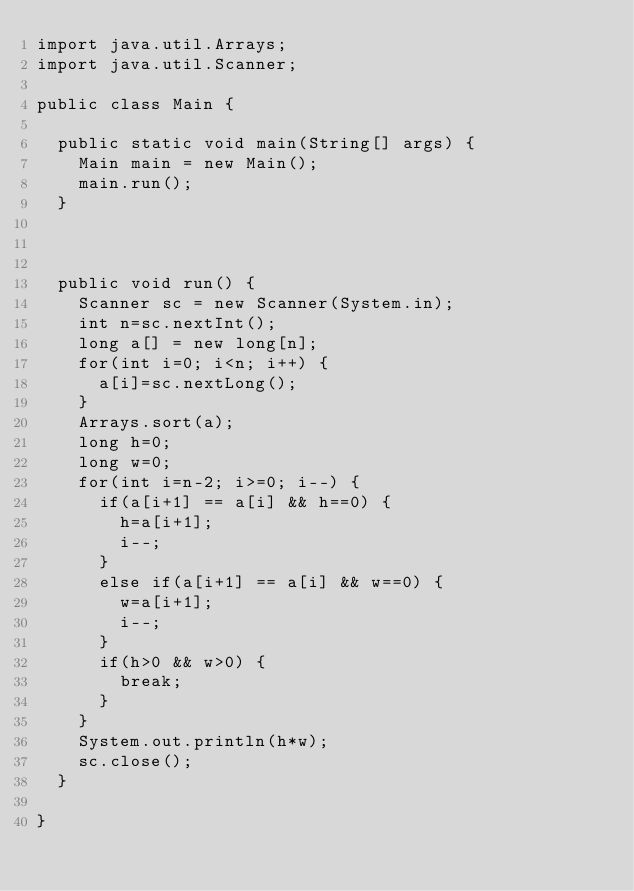Convert code to text. <code><loc_0><loc_0><loc_500><loc_500><_Java_>import java.util.Arrays;
import java.util.Scanner;

public class Main {

	public static void main(String[] args) {
		Main main = new Main();
		main.run();
	}



	public void run() {
		Scanner sc = new Scanner(System.in);
		int n=sc.nextInt();
		long a[] = new long[n];
		for(int i=0; i<n; i++) {
			a[i]=sc.nextLong();
		}
		Arrays.sort(a);
		long h=0;
		long w=0;
		for(int i=n-2; i>=0; i--) {
			if(a[i+1] == a[i] && h==0) {
				h=a[i+1];
				i--;
			}
			else if(a[i+1] == a[i] && w==0) {
				w=a[i+1];
				i--;
			}
			if(h>0 && w>0) {
				break;
			}
		}
		System.out.println(h*w);
		sc.close();
	}

}
</code> 